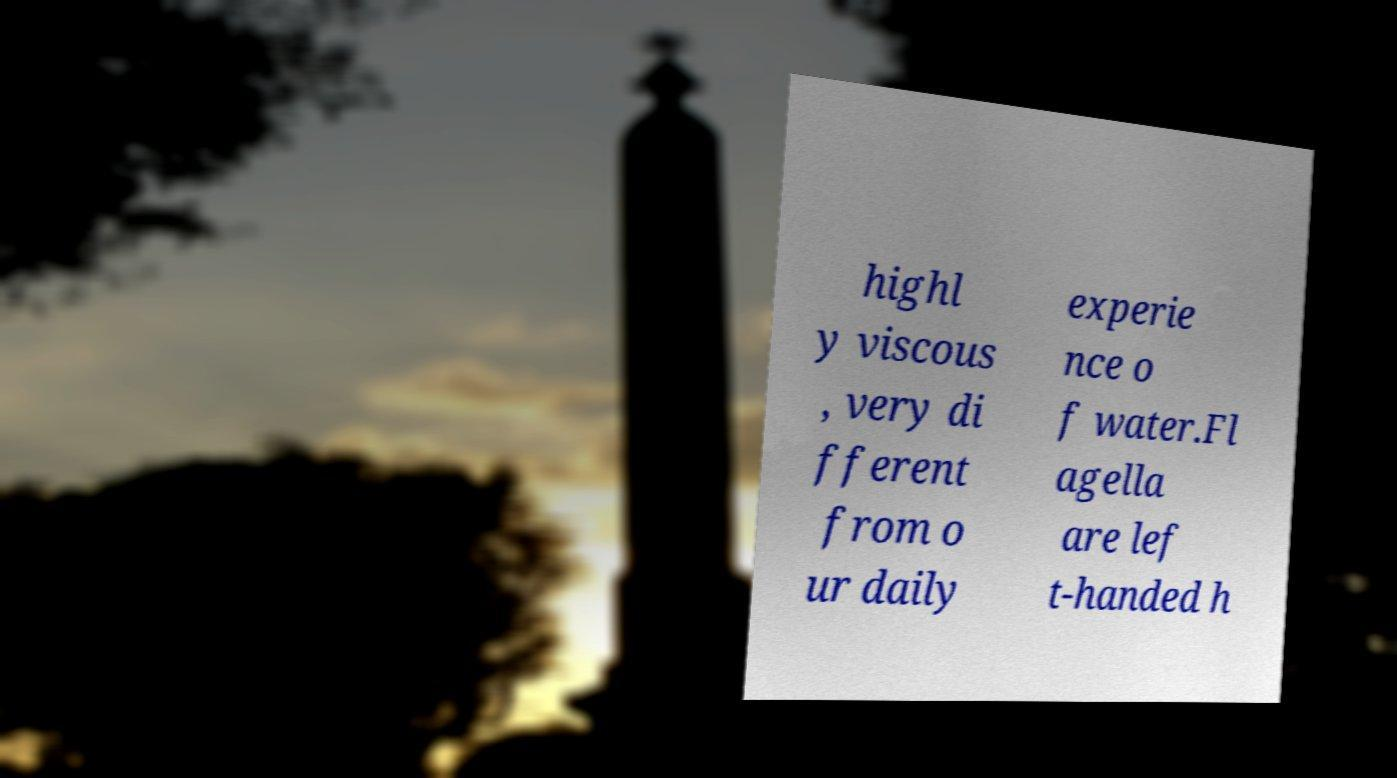I need the written content from this picture converted into text. Can you do that? highl y viscous , very di fferent from o ur daily experie nce o f water.Fl agella are lef t-handed h 